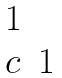Convert formula to latex. <formula><loc_0><loc_0><loc_500><loc_500>\begin{matrix} 1 & \\ c & 1 \end{matrix}</formula> 